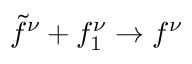<formula> <loc_0><loc_0><loc_500><loc_500>\tilde { f } ^ { \nu } + f _ { 1 } ^ { \nu } \to f ^ { \nu }</formula> 